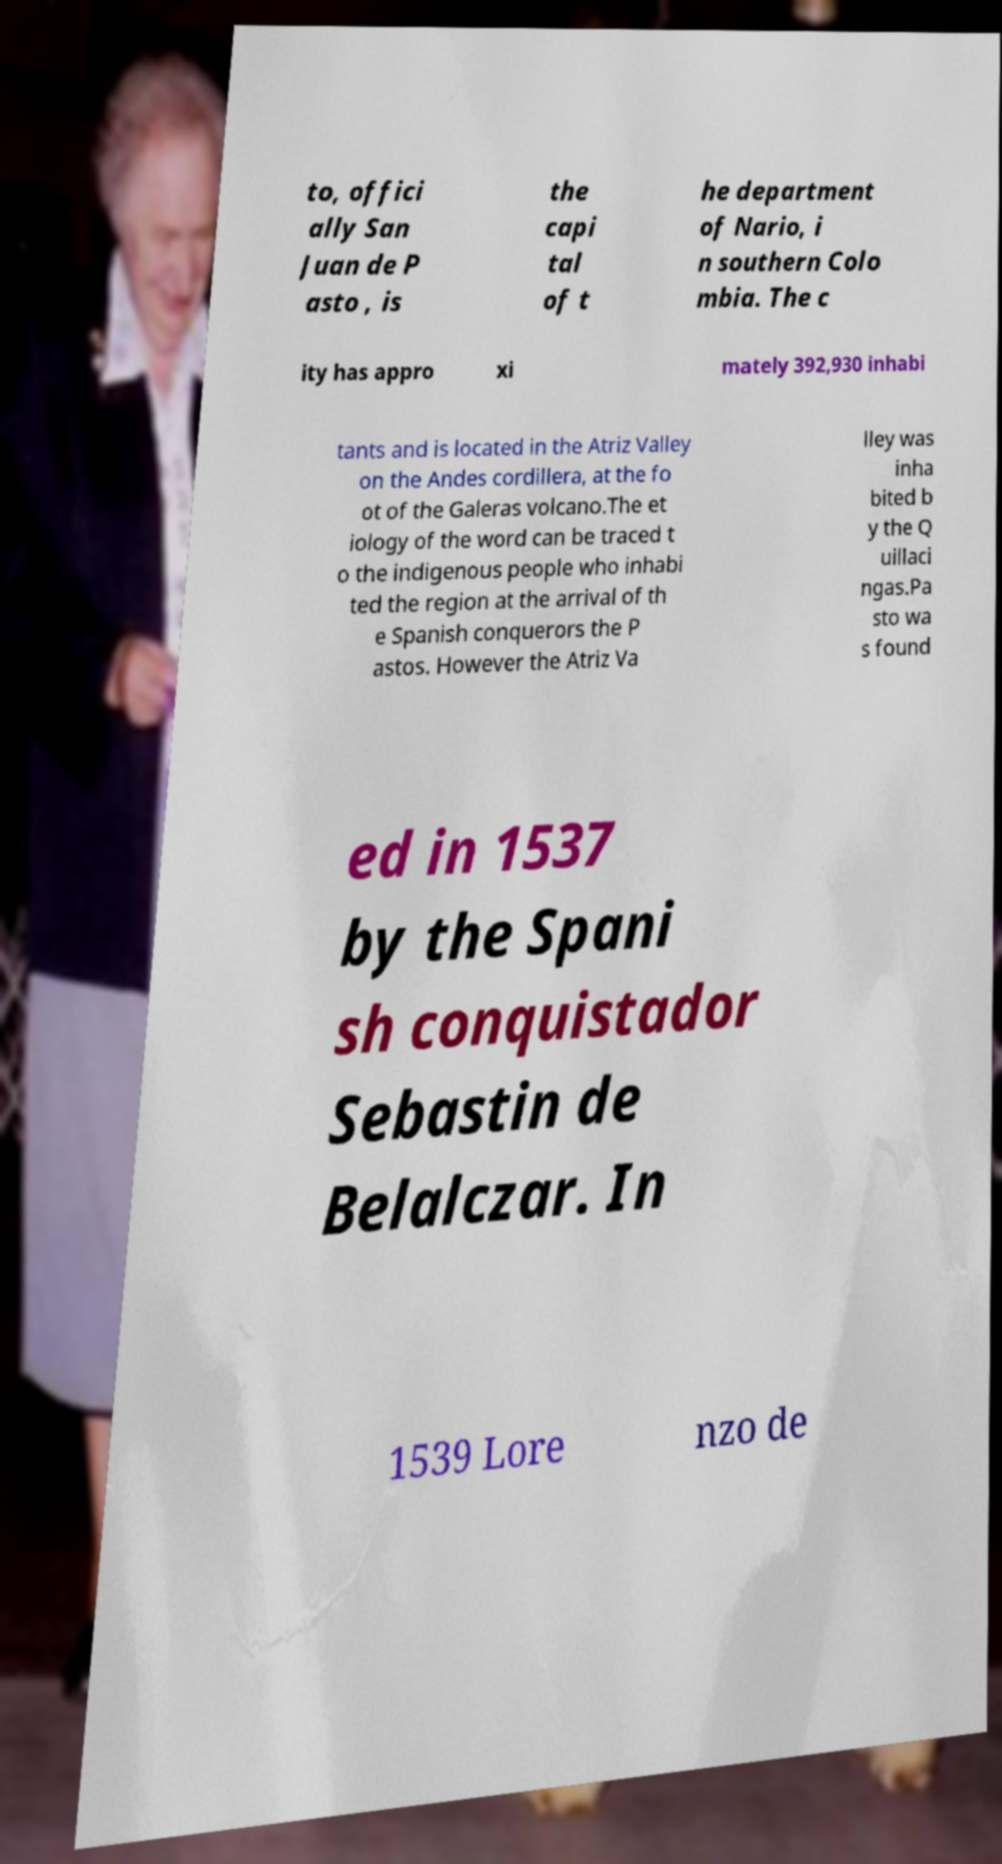Can you accurately transcribe the text from the provided image for me? to, offici ally San Juan de P asto , is the capi tal of t he department of Nario, i n southern Colo mbia. The c ity has appro xi mately 392,930 inhabi tants and is located in the Atriz Valley on the Andes cordillera, at the fo ot of the Galeras volcano.The et iology of the word can be traced t o the indigenous people who inhabi ted the region at the arrival of th e Spanish conquerors the P astos. However the Atriz Va lley was inha bited b y the Q uillaci ngas.Pa sto wa s found ed in 1537 by the Spani sh conquistador Sebastin de Belalczar. In 1539 Lore nzo de 